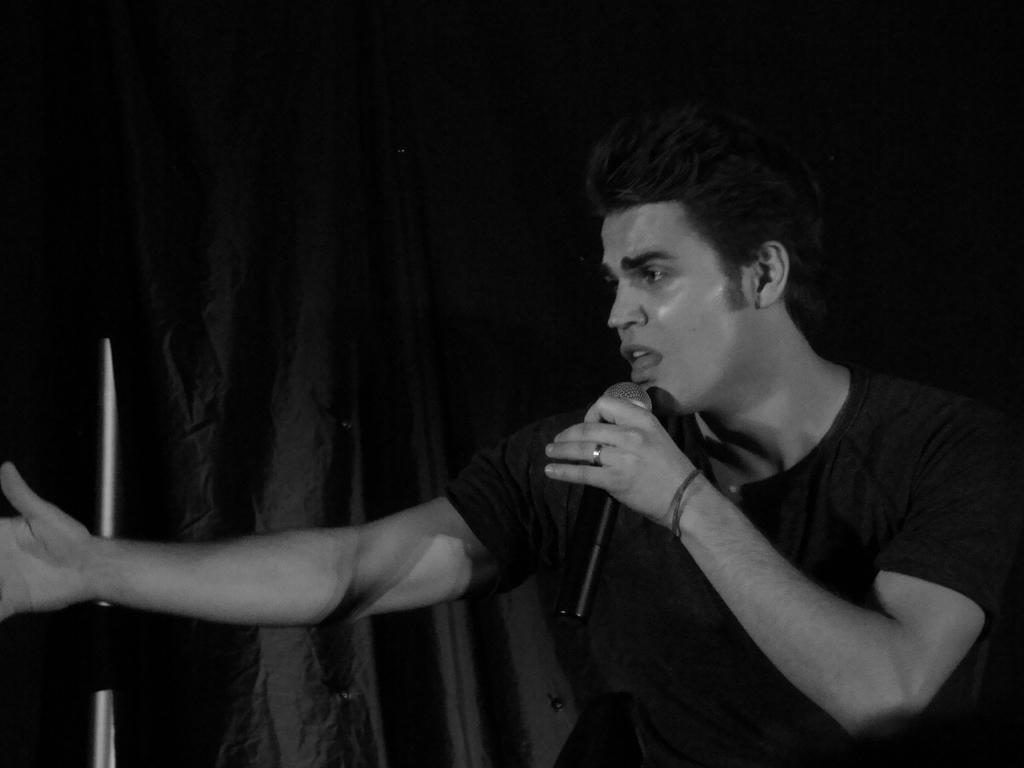Can you describe this image briefly? In this image we can see a man holding a mic in his hand. In the background there is a curtain. 